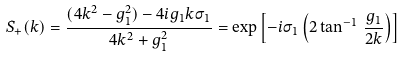Convert formula to latex. <formula><loc_0><loc_0><loc_500><loc_500>S _ { + } ( k ) = \frac { ( 4 k ^ { 2 } - g _ { 1 } ^ { 2 } ) - 4 i g _ { 1 } k \sigma _ { 1 } } { 4 k ^ { 2 } + g _ { 1 } ^ { 2 } } = \exp \left [ - i \sigma _ { 1 } \left ( 2 \tan ^ { - 1 } \, \frac { g _ { 1 } } { 2 k } \right ) \right ]</formula> 